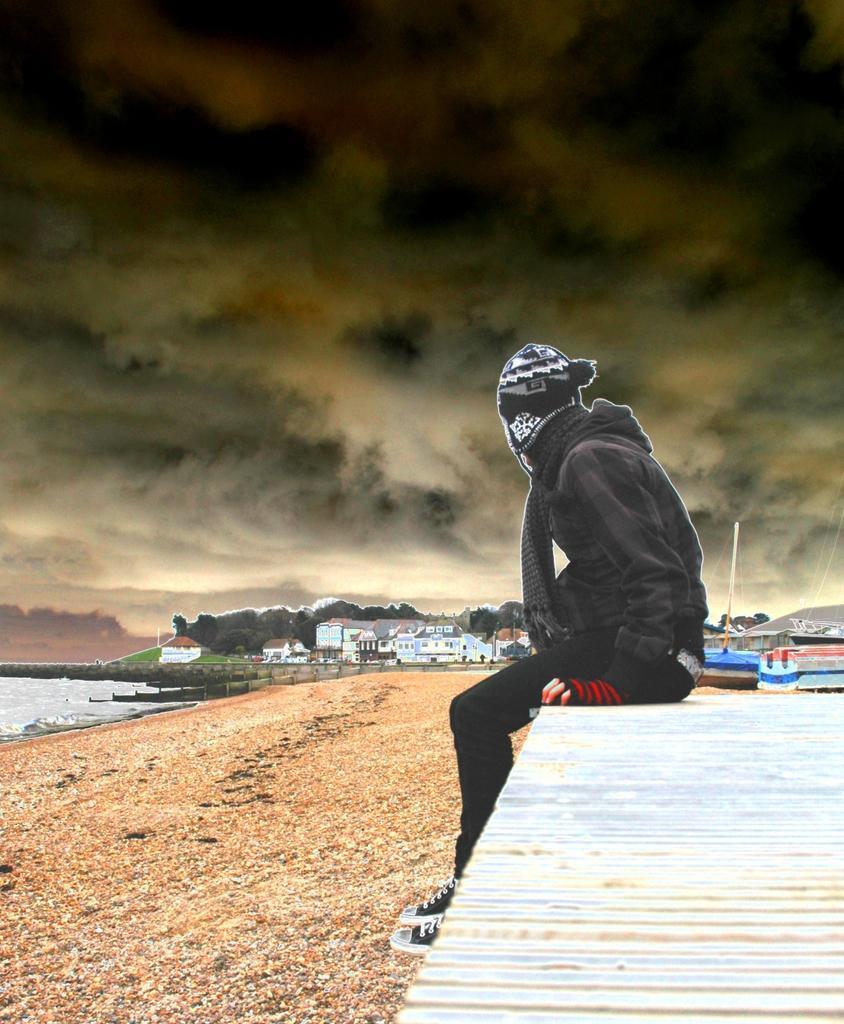How would you summarize this image in a sentence or two? In this picture we can see a person sitting on the right side, on the left side we can see water, in the background there are some buildings, we can see the sky at the top of the picture. 